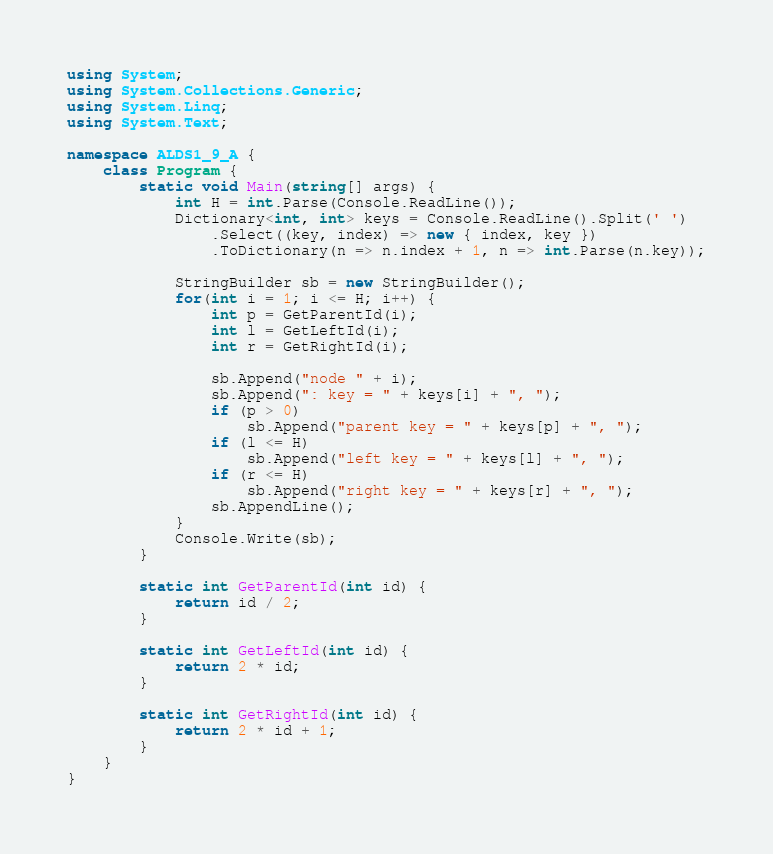Convert code to text. <code><loc_0><loc_0><loc_500><loc_500><_C#_>using System;
using System.Collections.Generic;
using System.Linq;
using System.Text;

namespace ALDS1_9_A {
    class Program {
        static void Main(string[] args) {
            int H = int.Parse(Console.ReadLine());
            Dictionary<int, int> keys = Console.ReadLine().Split(' ')
                .Select((key, index) => new { index, key })
                .ToDictionary(n => n.index + 1, n => int.Parse(n.key));

            StringBuilder sb = new StringBuilder();
            for(int i = 1; i <= H; i++) {
                int p = GetParentId(i);
                int l = GetLeftId(i);
                int r = GetRightId(i);

                sb.Append("node " + i);
                sb.Append(": key = " + keys[i] + ", ");
                if (p > 0)
                    sb.Append("parent key = " + keys[p] + ", ");
                if (l <= H)
                    sb.Append("left key = " + keys[l] + ", ");
                if (r <= H)
                    sb.Append("right key = " + keys[r] + ", ");
                sb.AppendLine();
            }
            Console.Write(sb);
        }

        static int GetParentId(int id) {
            return id / 2;
        }

        static int GetLeftId(int id) {
            return 2 * id;
        }

        static int GetRightId(int id) {
            return 2 * id + 1;
        }
    }
}</code> 